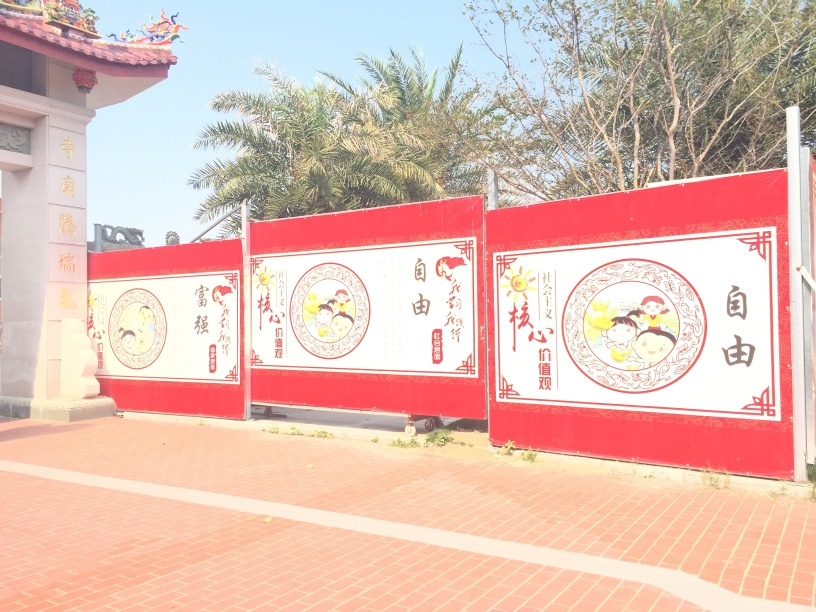Can you tell me what the illustrations on the panels represent? The illustrations on the red panels seem to depict traditional scenes or symbols, which might be related to cultural stories, celebrations, or historical events. Each panel appears to contain a circular design with different characters or motifs, suggesting these may have specific meanings or relate to certain festivities, possibly linked to Chinese culture given the use of Chinese characters. 